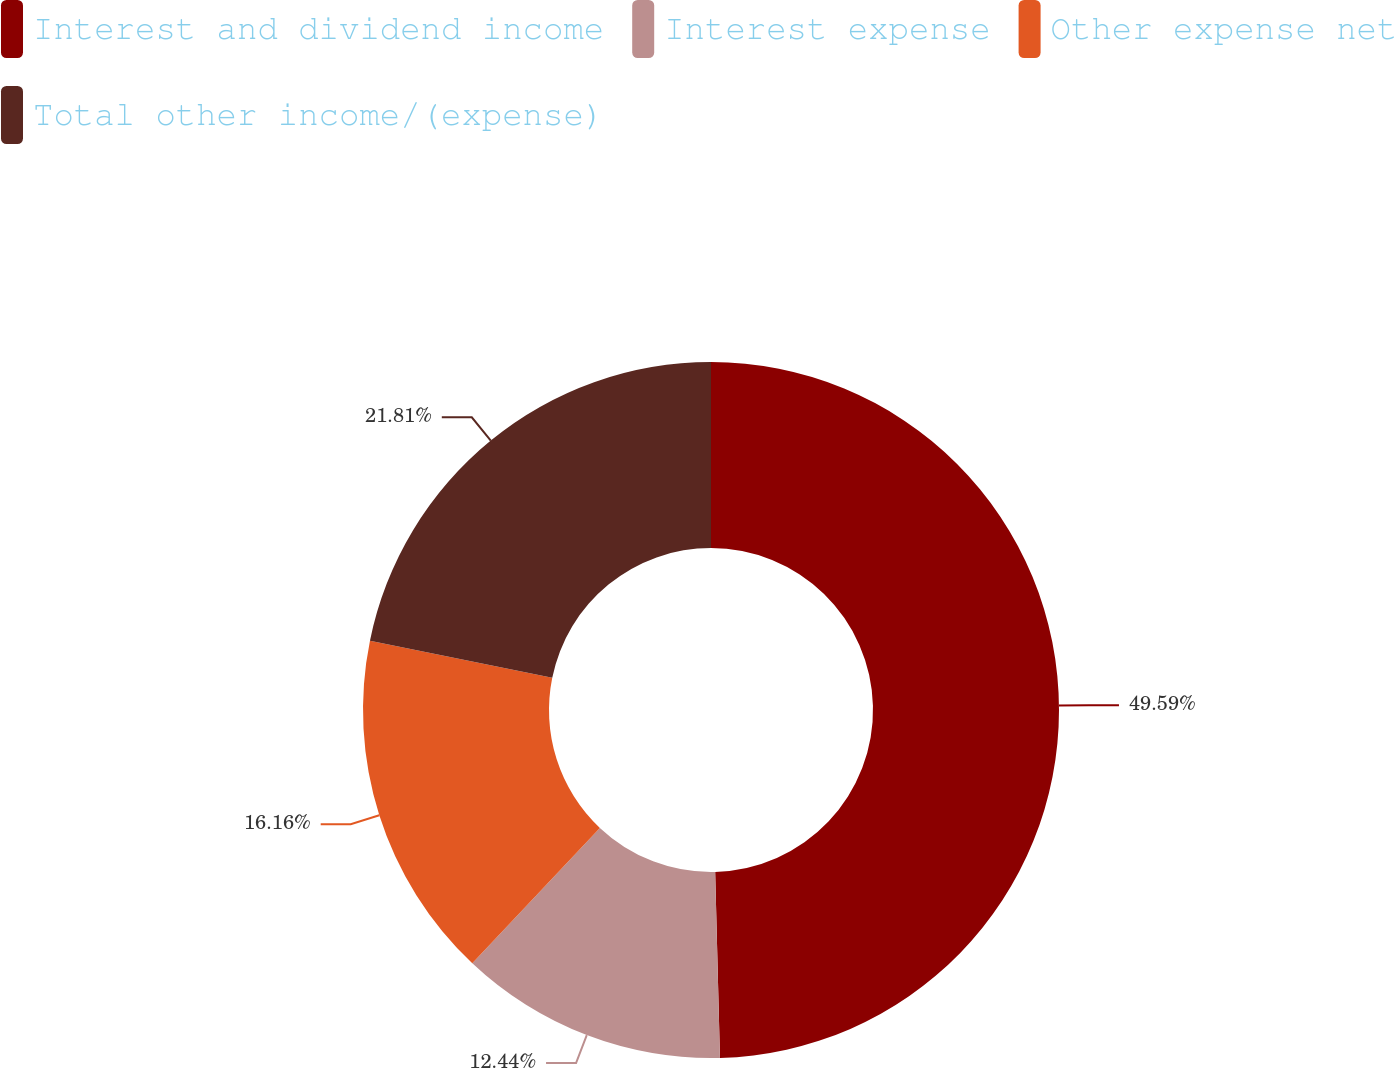Convert chart. <chart><loc_0><loc_0><loc_500><loc_500><pie_chart><fcel>Interest and dividend income<fcel>Interest expense<fcel>Other expense net<fcel>Total other income/(expense)<nl><fcel>49.59%<fcel>12.44%<fcel>16.16%<fcel>21.81%<nl></chart> 